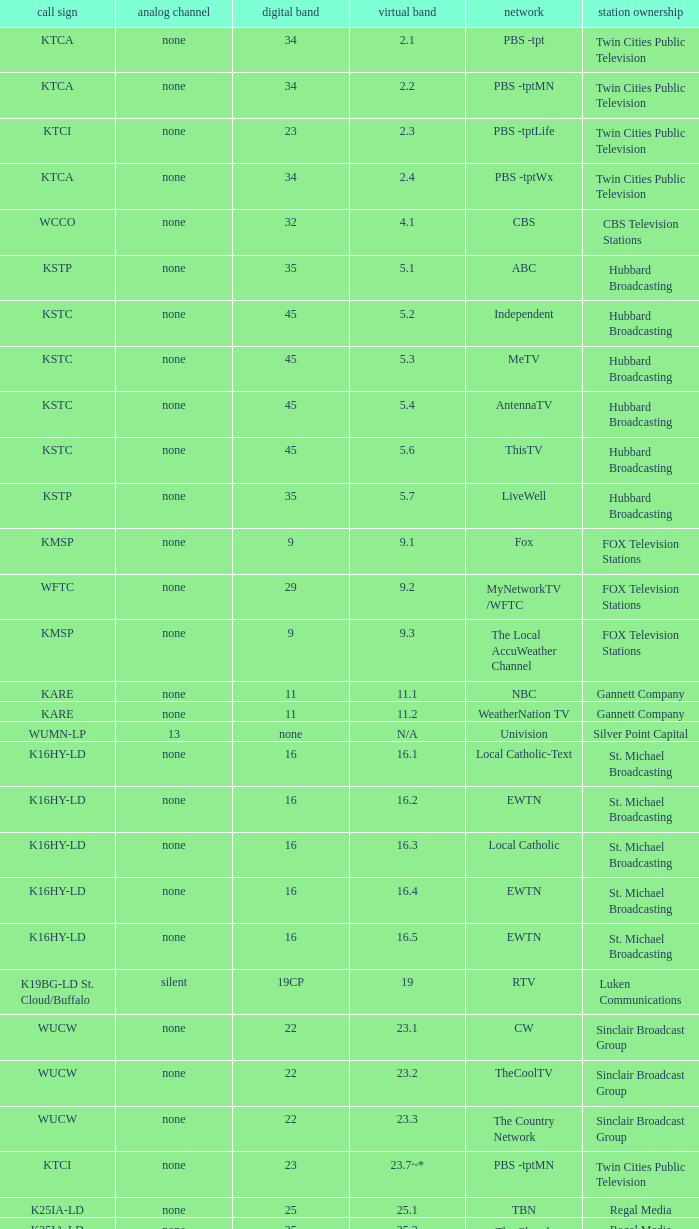For the call sign k33ln-ld and virtual channel 3 3ABN Radio-Audio. 